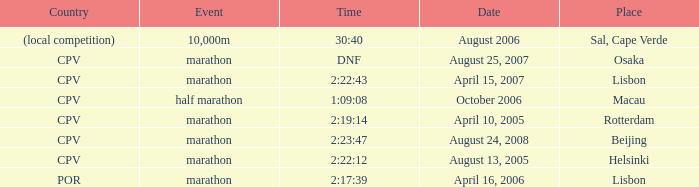What's the meaning of the event titled country of (local competition)? 10,000m. 